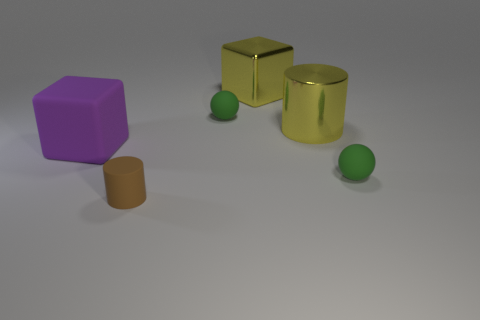Does the large rubber block have the same color as the big metallic cube?
Make the answer very short. No. There is a green thing behind the purple rubber thing that is to the left of the large yellow block; what is it made of?
Offer a very short reply. Rubber. What material is the other thing that is the same shape as the large rubber object?
Your answer should be very brief. Metal. Are there any large yellow blocks that are behind the large cube that is right of the tiny green object that is to the left of the big cylinder?
Make the answer very short. No. How many other objects are the same color as the tiny rubber cylinder?
Ensure brevity in your answer.  0. How many objects are both in front of the big yellow metallic block and on the left side of the big yellow cylinder?
Offer a very short reply. 3. What is the shape of the purple thing?
Your response must be concise. Cube. How many other things are there of the same material as the large purple cube?
Offer a terse response. 3. The small sphere that is left of the tiny green sphere in front of the big thing that is left of the brown thing is what color?
Offer a terse response. Green. There is another block that is the same size as the purple rubber cube; what is it made of?
Make the answer very short. Metal. 